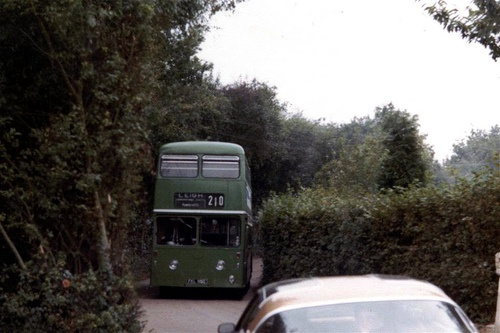Describe the objects in this image and their specific colors. I can see bus in black, gray, and darkgray tones and car in black, lightgray, gray, and darkgray tones in this image. 